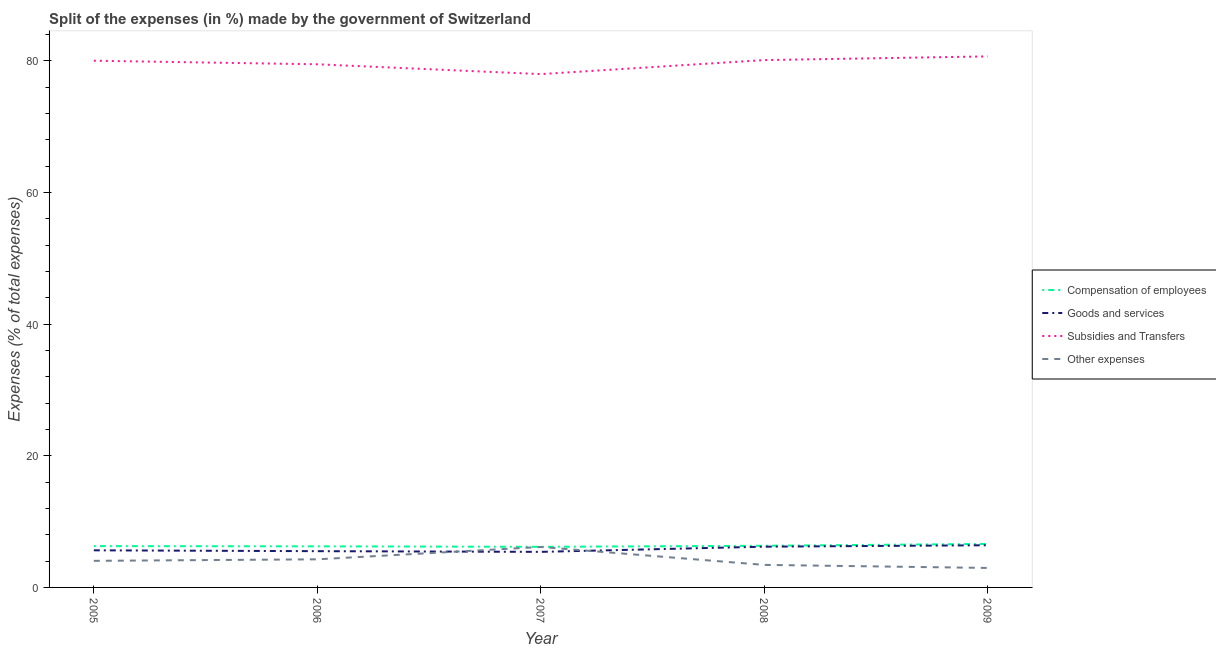How many different coloured lines are there?
Make the answer very short. 4. Does the line corresponding to percentage of amount spent on compensation of employees intersect with the line corresponding to percentage of amount spent on other expenses?
Provide a short and direct response. No. Is the number of lines equal to the number of legend labels?
Offer a very short reply. Yes. What is the percentage of amount spent on compensation of employees in 2007?
Offer a terse response. 6.17. Across all years, what is the maximum percentage of amount spent on compensation of employees?
Give a very brief answer. 6.61. Across all years, what is the minimum percentage of amount spent on other expenses?
Your answer should be compact. 2.96. In which year was the percentage of amount spent on compensation of employees maximum?
Ensure brevity in your answer.  2009. What is the total percentage of amount spent on subsidies in the graph?
Ensure brevity in your answer.  398.27. What is the difference between the percentage of amount spent on subsidies in 2008 and that in 2009?
Keep it short and to the point. -0.56. What is the difference between the percentage of amount spent on other expenses in 2009 and the percentage of amount spent on goods and services in 2005?
Your answer should be compact. -2.68. What is the average percentage of amount spent on goods and services per year?
Ensure brevity in your answer.  5.83. In the year 2006, what is the difference between the percentage of amount spent on other expenses and percentage of amount spent on compensation of employees?
Ensure brevity in your answer.  -1.97. What is the ratio of the percentage of amount spent on subsidies in 2007 to that in 2009?
Your answer should be very brief. 0.97. Is the difference between the percentage of amount spent on goods and services in 2006 and 2007 greater than the difference between the percentage of amount spent on other expenses in 2006 and 2007?
Your response must be concise. Yes. What is the difference between the highest and the second highest percentage of amount spent on compensation of employees?
Make the answer very short. 0.28. What is the difference between the highest and the lowest percentage of amount spent on compensation of employees?
Keep it short and to the point. 0.44. In how many years, is the percentage of amount spent on other expenses greater than the average percentage of amount spent on other expenses taken over all years?
Your response must be concise. 2. Is it the case that in every year, the sum of the percentage of amount spent on compensation of employees and percentage of amount spent on other expenses is greater than the sum of percentage of amount spent on subsidies and percentage of amount spent on goods and services?
Keep it short and to the point. No. Is it the case that in every year, the sum of the percentage of amount spent on compensation of employees and percentage of amount spent on goods and services is greater than the percentage of amount spent on subsidies?
Ensure brevity in your answer.  No. How many lines are there?
Ensure brevity in your answer.  4. How many years are there in the graph?
Make the answer very short. 5. What is the difference between two consecutive major ticks on the Y-axis?
Ensure brevity in your answer.  20. Does the graph contain any zero values?
Your answer should be very brief. No. Where does the legend appear in the graph?
Offer a very short reply. Center right. How many legend labels are there?
Your answer should be compact. 4. How are the legend labels stacked?
Your answer should be very brief. Vertical. What is the title of the graph?
Offer a very short reply. Split of the expenses (in %) made by the government of Switzerland. Does "Coal" appear as one of the legend labels in the graph?
Offer a very short reply. No. What is the label or title of the X-axis?
Give a very brief answer. Year. What is the label or title of the Y-axis?
Keep it short and to the point. Expenses (% of total expenses). What is the Expenses (% of total expenses) of Compensation of employees in 2005?
Provide a succinct answer. 6.28. What is the Expenses (% of total expenses) in Goods and services in 2005?
Give a very brief answer. 5.64. What is the Expenses (% of total expenses) of Subsidies and Transfers in 2005?
Keep it short and to the point. 80.02. What is the Expenses (% of total expenses) of Other expenses in 2005?
Give a very brief answer. 4.04. What is the Expenses (% of total expenses) of Compensation of employees in 2006?
Provide a succinct answer. 6.24. What is the Expenses (% of total expenses) of Goods and services in 2006?
Provide a short and direct response. 5.51. What is the Expenses (% of total expenses) in Subsidies and Transfers in 2006?
Provide a succinct answer. 79.48. What is the Expenses (% of total expenses) of Other expenses in 2006?
Your response must be concise. 4.27. What is the Expenses (% of total expenses) in Compensation of employees in 2007?
Provide a succinct answer. 6.17. What is the Expenses (% of total expenses) in Goods and services in 2007?
Provide a succinct answer. 5.4. What is the Expenses (% of total expenses) of Subsidies and Transfers in 2007?
Your answer should be compact. 77.99. What is the Expenses (% of total expenses) of Other expenses in 2007?
Your response must be concise. 6.15. What is the Expenses (% of total expenses) in Compensation of employees in 2008?
Provide a succinct answer. 6.33. What is the Expenses (% of total expenses) in Goods and services in 2008?
Your response must be concise. 6.19. What is the Expenses (% of total expenses) in Subsidies and Transfers in 2008?
Make the answer very short. 80.12. What is the Expenses (% of total expenses) in Other expenses in 2008?
Make the answer very short. 3.42. What is the Expenses (% of total expenses) in Compensation of employees in 2009?
Ensure brevity in your answer.  6.61. What is the Expenses (% of total expenses) in Goods and services in 2009?
Your response must be concise. 6.41. What is the Expenses (% of total expenses) in Subsidies and Transfers in 2009?
Give a very brief answer. 80.68. What is the Expenses (% of total expenses) of Other expenses in 2009?
Keep it short and to the point. 2.96. Across all years, what is the maximum Expenses (% of total expenses) of Compensation of employees?
Your answer should be compact. 6.61. Across all years, what is the maximum Expenses (% of total expenses) in Goods and services?
Provide a succinct answer. 6.41. Across all years, what is the maximum Expenses (% of total expenses) of Subsidies and Transfers?
Give a very brief answer. 80.68. Across all years, what is the maximum Expenses (% of total expenses) in Other expenses?
Keep it short and to the point. 6.15. Across all years, what is the minimum Expenses (% of total expenses) of Compensation of employees?
Make the answer very short. 6.17. Across all years, what is the minimum Expenses (% of total expenses) in Goods and services?
Offer a terse response. 5.4. Across all years, what is the minimum Expenses (% of total expenses) of Subsidies and Transfers?
Provide a short and direct response. 77.99. Across all years, what is the minimum Expenses (% of total expenses) of Other expenses?
Offer a terse response. 2.96. What is the total Expenses (% of total expenses) in Compensation of employees in the graph?
Ensure brevity in your answer.  31.63. What is the total Expenses (% of total expenses) in Goods and services in the graph?
Make the answer very short. 29.15. What is the total Expenses (% of total expenses) of Subsidies and Transfers in the graph?
Provide a succinct answer. 398.27. What is the total Expenses (% of total expenses) of Other expenses in the graph?
Provide a short and direct response. 20.84. What is the difference between the Expenses (% of total expenses) of Compensation of employees in 2005 and that in 2006?
Make the answer very short. 0.03. What is the difference between the Expenses (% of total expenses) of Goods and services in 2005 and that in 2006?
Offer a terse response. 0.13. What is the difference between the Expenses (% of total expenses) in Subsidies and Transfers in 2005 and that in 2006?
Make the answer very short. 0.54. What is the difference between the Expenses (% of total expenses) in Other expenses in 2005 and that in 2006?
Your response must be concise. -0.23. What is the difference between the Expenses (% of total expenses) of Compensation of employees in 2005 and that in 2007?
Give a very brief answer. 0.11. What is the difference between the Expenses (% of total expenses) in Goods and services in 2005 and that in 2007?
Offer a very short reply. 0.23. What is the difference between the Expenses (% of total expenses) of Subsidies and Transfers in 2005 and that in 2007?
Offer a very short reply. 2.03. What is the difference between the Expenses (% of total expenses) in Other expenses in 2005 and that in 2007?
Give a very brief answer. -2.11. What is the difference between the Expenses (% of total expenses) in Compensation of employees in 2005 and that in 2008?
Offer a terse response. -0.05. What is the difference between the Expenses (% of total expenses) in Goods and services in 2005 and that in 2008?
Offer a terse response. -0.55. What is the difference between the Expenses (% of total expenses) of Subsidies and Transfers in 2005 and that in 2008?
Offer a terse response. -0.1. What is the difference between the Expenses (% of total expenses) in Other expenses in 2005 and that in 2008?
Your response must be concise. 0.61. What is the difference between the Expenses (% of total expenses) of Compensation of employees in 2005 and that in 2009?
Your answer should be compact. -0.33. What is the difference between the Expenses (% of total expenses) in Goods and services in 2005 and that in 2009?
Provide a short and direct response. -0.77. What is the difference between the Expenses (% of total expenses) in Subsidies and Transfers in 2005 and that in 2009?
Provide a succinct answer. -0.66. What is the difference between the Expenses (% of total expenses) in Other expenses in 2005 and that in 2009?
Provide a short and direct response. 1.08. What is the difference between the Expenses (% of total expenses) of Compensation of employees in 2006 and that in 2007?
Offer a very short reply. 0.08. What is the difference between the Expenses (% of total expenses) of Goods and services in 2006 and that in 2007?
Offer a very short reply. 0.11. What is the difference between the Expenses (% of total expenses) of Subsidies and Transfers in 2006 and that in 2007?
Offer a terse response. 1.49. What is the difference between the Expenses (% of total expenses) of Other expenses in 2006 and that in 2007?
Your answer should be compact. -1.88. What is the difference between the Expenses (% of total expenses) in Compensation of employees in 2006 and that in 2008?
Ensure brevity in your answer.  -0.09. What is the difference between the Expenses (% of total expenses) in Goods and services in 2006 and that in 2008?
Ensure brevity in your answer.  -0.68. What is the difference between the Expenses (% of total expenses) in Subsidies and Transfers in 2006 and that in 2008?
Ensure brevity in your answer.  -0.64. What is the difference between the Expenses (% of total expenses) in Other expenses in 2006 and that in 2008?
Offer a very short reply. 0.84. What is the difference between the Expenses (% of total expenses) of Compensation of employees in 2006 and that in 2009?
Give a very brief answer. -0.36. What is the difference between the Expenses (% of total expenses) in Goods and services in 2006 and that in 2009?
Provide a succinct answer. -0.9. What is the difference between the Expenses (% of total expenses) in Subsidies and Transfers in 2006 and that in 2009?
Ensure brevity in your answer.  -1.2. What is the difference between the Expenses (% of total expenses) of Other expenses in 2006 and that in 2009?
Keep it short and to the point. 1.31. What is the difference between the Expenses (% of total expenses) of Compensation of employees in 2007 and that in 2008?
Provide a short and direct response. -0.16. What is the difference between the Expenses (% of total expenses) of Goods and services in 2007 and that in 2008?
Make the answer very short. -0.79. What is the difference between the Expenses (% of total expenses) of Subsidies and Transfers in 2007 and that in 2008?
Your response must be concise. -2.13. What is the difference between the Expenses (% of total expenses) of Other expenses in 2007 and that in 2008?
Provide a succinct answer. 2.72. What is the difference between the Expenses (% of total expenses) of Compensation of employees in 2007 and that in 2009?
Keep it short and to the point. -0.44. What is the difference between the Expenses (% of total expenses) in Goods and services in 2007 and that in 2009?
Your answer should be compact. -1. What is the difference between the Expenses (% of total expenses) of Subsidies and Transfers in 2007 and that in 2009?
Provide a short and direct response. -2.69. What is the difference between the Expenses (% of total expenses) of Other expenses in 2007 and that in 2009?
Your answer should be very brief. 3.19. What is the difference between the Expenses (% of total expenses) in Compensation of employees in 2008 and that in 2009?
Offer a terse response. -0.28. What is the difference between the Expenses (% of total expenses) of Goods and services in 2008 and that in 2009?
Provide a succinct answer. -0.22. What is the difference between the Expenses (% of total expenses) in Subsidies and Transfers in 2008 and that in 2009?
Provide a short and direct response. -0.56. What is the difference between the Expenses (% of total expenses) in Other expenses in 2008 and that in 2009?
Ensure brevity in your answer.  0.46. What is the difference between the Expenses (% of total expenses) of Compensation of employees in 2005 and the Expenses (% of total expenses) of Goods and services in 2006?
Offer a very short reply. 0.77. What is the difference between the Expenses (% of total expenses) of Compensation of employees in 2005 and the Expenses (% of total expenses) of Subsidies and Transfers in 2006?
Provide a short and direct response. -73.2. What is the difference between the Expenses (% of total expenses) of Compensation of employees in 2005 and the Expenses (% of total expenses) of Other expenses in 2006?
Ensure brevity in your answer.  2.01. What is the difference between the Expenses (% of total expenses) in Goods and services in 2005 and the Expenses (% of total expenses) in Subsidies and Transfers in 2006?
Offer a terse response. -73.84. What is the difference between the Expenses (% of total expenses) of Goods and services in 2005 and the Expenses (% of total expenses) of Other expenses in 2006?
Ensure brevity in your answer.  1.37. What is the difference between the Expenses (% of total expenses) of Subsidies and Transfers in 2005 and the Expenses (% of total expenses) of Other expenses in 2006?
Your answer should be compact. 75.75. What is the difference between the Expenses (% of total expenses) in Compensation of employees in 2005 and the Expenses (% of total expenses) in Goods and services in 2007?
Your answer should be very brief. 0.88. What is the difference between the Expenses (% of total expenses) in Compensation of employees in 2005 and the Expenses (% of total expenses) in Subsidies and Transfers in 2007?
Offer a terse response. -71.71. What is the difference between the Expenses (% of total expenses) of Compensation of employees in 2005 and the Expenses (% of total expenses) of Other expenses in 2007?
Give a very brief answer. 0.13. What is the difference between the Expenses (% of total expenses) of Goods and services in 2005 and the Expenses (% of total expenses) of Subsidies and Transfers in 2007?
Your answer should be very brief. -72.35. What is the difference between the Expenses (% of total expenses) of Goods and services in 2005 and the Expenses (% of total expenses) of Other expenses in 2007?
Keep it short and to the point. -0.51. What is the difference between the Expenses (% of total expenses) in Subsidies and Transfers in 2005 and the Expenses (% of total expenses) in Other expenses in 2007?
Ensure brevity in your answer.  73.87. What is the difference between the Expenses (% of total expenses) in Compensation of employees in 2005 and the Expenses (% of total expenses) in Goods and services in 2008?
Make the answer very short. 0.09. What is the difference between the Expenses (% of total expenses) of Compensation of employees in 2005 and the Expenses (% of total expenses) of Subsidies and Transfers in 2008?
Give a very brief answer. -73.84. What is the difference between the Expenses (% of total expenses) of Compensation of employees in 2005 and the Expenses (% of total expenses) of Other expenses in 2008?
Keep it short and to the point. 2.85. What is the difference between the Expenses (% of total expenses) of Goods and services in 2005 and the Expenses (% of total expenses) of Subsidies and Transfers in 2008?
Your answer should be compact. -74.48. What is the difference between the Expenses (% of total expenses) of Goods and services in 2005 and the Expenses (% of total expenses) of Other expenses in 2008?
Give a very brief answer. 2.21. What is the difference between the Expenses (% of total expenses) in Subsidies and Transfers in 2005 and the Expenses (% of total expenses) in Other expenses in 2008?
Your answer should be compact. 76.6. What is the difference between the Expenses (% of total expenses) of Compensation of employees in 2005 and the Expenses (% of total expenses) of Goods and services in 2009?
Ensure brevity in your answer.  -0.13. What is the difference between the Expenses (% of total expenses) in Compensation of employees in 2005 and the Expenses (% of total expenses) in Subsidies and Transfers in 2009?
Your answer should be compact. -74.4. What is the difference between the Expenses (% of total expenses) of Compensation of employees in 2005 and the Expenses (% of total expenses) of Other expenses in 2009?
Your response must be concise. 3.32. What is the difference between the Expenses (% of total expenses) of Goods and services in 2005 and the Expenses (% of total expenses) of Subsidies and Transfers in 2009?
Offer a terse response. -75.04. What is the difference between the Expenses (% of total expenses) in Goods and services in 2005 and the Expenses (% of total expenses) in Other expenses in 2009?
Offer a very short reply. 2.68. What is the difference between the Expenses (% of total expenses) in Subsidies and Transfers in 2005 and the Expenses (% of total expenses) in Other expenses in 2009?
Your response must be concise. 77.06. What is the difference between the Expenses (% of total expenses) in Compensation of employees in 2006 and the Expenses (% of total expenses) in Goods and services in 2007?
Your answer should be compact. 0.84. What is the difference between the Expenses (% of total expenses) of Compensation of employees in 2006 and the Expenses (% of total expenses) of Subsidies and Transfers in 2007?
Give a very brief answer. -71.74. What is the difference between the Expenses (% of total expenses) in Compensation of employees in 2006 and the Expenses (% of total expenses) in Other expenses in 2007?
Give a very brief answer. 0.1. What is the difference between the Expenses (% of total expenses) of Goods and services in 2006 and the Expenses (% of total expenses) of Subsidies and Transfers in 2007?
Provide a short and direct response. -72.48. What is the difference between the Expenses (% of total expenses) in Goods and services in 2006 and the Expenses (% of total expenses) in Other expenses in 2007?
Your answer should be very brief. -0.64. What is the difference between the Expenses (% of total expenses) of Subsidies and Transfers in 2006 and the Expenses (% of total expenses) of Other expenses in 2007?
Offer a terse response. 73.33. What is the difference between the Expenses (% of total expenses) in Compensation of employees in 2006 and the Expenses (% of total expenses) in Goods and services in 2008?
Your response must be concise. 0.05. What is the difference between the Expenses (% of total expenses) in Compensation of employees in 2006 and the Expenses (% of total expenses) in Subsidies and Transfers in 2008?
Offer a terse response. -73.87. What is the difference between the Expenses (% of total expenses) in Compensation of employees in 2006 and the Expenses (% of total expenses) in Other expenses in 2008?
Your answer should be compact. 2.82. What is the difference between the Expenses (% of total expenses) in Goods and services in 2006 and the Expenses (% of total expenses) in Subsidies and Transfers in 2008?
Offer a terse response. -74.61. What is the difference between the Expenses (% of total expenses) of Goods and services in 2006 and the Expenses (% of total expenses) of Other expenses in 2008?
Provide a succinct answer. 2.08. What is the difference between the Expenses (% of total expenses) of Subsidies and Transfers in 2006 and the Expenses (% of total expenses) of Other expenses in 2008?
Offer a terse response. 76.05. What is the difference between the Expenses (% of total expenses) of Compensation of employees in 2006 and the Expenses (% of total expenses) of Goods and services in 2009?
Your answer should be very brief. -0.16. What is the difference between the Expenses (% of total expenses) of Compensation of employees in 2006 and the Expenses (% of total expenses) of Subsidies and Transfers in 2009?
Offer a very short reply. -74.43. What is the difference between the Expenses (% of total expenses) of Compensation of employees in 2006 and the Expenses (% of total expenses) of Other expenses in 2009?
Your answer should be very brief. 3.28. What is the difference between the Expenses (% of total expenses) in Goods and services in 2006 and the Expenses (% of total expenses) in Subsidies and Transfers in 2009?
Your response must be concise. -75.17. What is the difference between the Expenses (% of total expenses) in Goods and services in 2006 and the Expenses (% of total expenses) in Other expenses in 2009?
Your response must be concise. 2.55. What is the difference between the Expenses (% of total expenses) of Subsidies and Transfers in 2006 and the Expenses (% of total expenses) of Other expenses in 2009?
Ensure brevity in your answer.  76.51. What is the difference between the Expenses (% of total expenses) of Compensation of employees in 2007 and the Expenses (% of total expenses) of Goods and services in 2008?
Offer a terse response. -0.02. What is the difference between the Expenses (% of total expenses) in Compensation of employees in 2007 and the Expenses (% of total expenses) in Subsidies and Transfers in 2008?
Offer a terse response. -73.95. What is the difference between the Expenses (% of total expenses) in Compensation of employees in 2007 and the Expenses (% of total expenses) in Other expenses in 2008?
Your answer should be compact. 2.74. What is the difference between the Expenses (% of total expenses) in Goods and services in 2007 and the Expenses (% of total expenses) in Subsidies and Transfers in 2008?
Offer a terse response. -74.71. What is the difference between the Expenses (% of total expenses) in Goods and services in 2007 and the Expenses (% of total expenses) in Other expenses in 2008?
Provide a short and direct response. 1.98. What is the difference between the Expenses (% of total expenses) in Subsidies and Transfers in 2007 and the Expenses (% of total expenses) in Other expenses in 2008?
Provide a short and direct response. 74.56. What is the difference between the Expenses (% of total expenses) of Compensation of employees in 2007 and the Expenses (% of total expenses) of Goods and services in 2009?
Provide a succinct answer. -0.24. What is the difference between the Expenses (% of total expenses) of Compensation of employees in 2007 and the Expenses (% of total expenses) of Subsidies and Transfers in 2009?
Ensure brevity in your answer.  -74.51. What is the difference between the Expenses (% of total expenses) of Compensation of employees in 2007 and the Expenses (% of total expenses) of Other expenses in 2009?
Offer a terse response. 3.21. What is the difference between the Expenses (% of total expenses) of Goods and services in 2007 and the Expenses (% of total expenses) of Subsidies and Transfers in 2009?
Provide a short and direct response. -75.27. What is the difference between the Expenses (% of total expenses) of Goods and services in 2007 and the Expenses (% of total expenses) of Other expenses in 2009?
Offer a very short reply. 2.44. What is the difference between the Expenses (% of total expenses) of Subsidies and Transfers in 2007 and the Expenses (% of total expenses) of Other expenses in 2009?
Keep it short and to the point. 75.03. What is the difference between the Expenses (% of total expenses) in Compensation of employees in 2008 and the Expenses (% of total expenses) in Goods and services in 2009?
Your response must be concise. -0.08. What is the difference between the Expenses (% of total expenses) of Compensation of employees in 2008 and the Expenses (% of total expenses) of Subsidies and Transfers in 2009?
Make the answer very short. -74.35. What is the difference between the Expenses (% of total expenses) of Compensation of employees in 2008 and the Expenses (% of total expenses) of Other expenses in 2009?
Your answer should be compact. 3.37. What is the difference between the Expenses (% of total expenses) of Goods and services in 2008 and the Expenses (% of total expenses) of Subsidies and Transfers in 2009?
Provide a succinct answer. -74.49. What is the difference between the Expenses (% of total expenses) in Goods and services in 2008 and the Expenses (% of total expenses) in Other expenses in 2009?
Your answer should be compact. 3.23. What is the difference between the Expenses (% of total expenses) in Subsidies and Transfers in 2008 and the Expenses (% of total expenses) in Other expenses in 2009?
Keep it short and to the point. 77.15. What is the average Expenses (% of total expenses) in Compensation of employees per year?
Your answer should be compact. 6.33. What is the average Expenses (% of total expenses) in Goods and services per year?
Keep it short and to the point. 5.83. What is the average Expenses (% of total expenses) of Subsidies and Transfers per year?
Make the answer very short. 79.65. What is the average Expenses (% of total expenses) in Other expenses per year?
Your answer should be compact. 4.17. In the year 2005, what is the difference between the Expenses (% of total expenses) of Compensation of employees and Expenses (% of total expenses) of Goods and services?
Keep it short and to the point. 0.64. In the year 2005, what is the difference between the Expenses (% of total expenses) in Compensation of employees and Expenses (% of total expenses) in Subsidies and Transfers?
Offer a terse response. -73.74. In the year 2005, what is the difference between the Expenses (% of total expenses) in Compensation of employees and Expenses (% of total expenses) in Other expenses?
Provide a short and direct response. 2.24. In the year 2005, what is the difference between the Expenses (% of total expenses) in Goods and services and Expenses (% of total expenses) in Subsidies and Transfers?
Your response must be concise. -74.38. In the year 2005, what is the difference between the Expenses (% of total expenses) in Goods and services and Expenses (% of total expenses) in Other expenses?
Provide a succinct answer. 1.6. In the year 2005, what is the difference between the Expenses (% of total expenses) in Subsidies and Transfers and Expenses (% of total expenses) in Other expenses?
Provide a succinct answer. 75.98. In the year 2006, what is the difference between the Expenses (% of total expenses) of Compensation of employees and Expenses (% of total expenses) of Goods and services?
Provide a succinct answer. 0.74. In the year 2006, what is the difference between the Expenses (% of total expenses) of Compensation of employees and Expenses (% of total expenses) of Subsidies and Transfers?
Ensure brevity in your answer.  -73.23. In the year 2006, what is the difference between the Expenses (% of total expenses) in Compensation of employees and Expenses (% of total expenses) in Other expenses?
Keep it short and to the point. 1.97. In the year 2006, what is the difference between the Expenses (% of total expenses) in Goods and services and Expenses (% of total expenses) in Subsidies and Transfers?
Your answer should be compact. -73.97. In the year 2006, what is the difference between the Expenses (% of total expenses) of Goods and services and Expenses (% of total expenses) of Other expenses?
Provide a succinct answer. 1.24. In the year 2006, what is the difference between the Expenses (% of total expenses) in Subsidies and Transfers and Expenses (% of total expenses) in Other expenses?
Provide a succinct answer. 75.21. In the year 2007, what is the difference between the Expenses (% of total expenses) in Compensation of employees and Expenses (% of total expenses) in Goods and services?
Give a very brief answer. 0.76. In the year 2007, what is the difference between the Expenses (% of total expenses) in Compensation of employees and Expenses (% of total expenses) in Subsidies and Transfers?
Offer a very short reply. -71.82. In the year 2007, what is the difference between the Expenses (% of total expenses) of Compensation of employees and Expenses (% of total expenses) of Other expenses?
Provide a succinct answer. 0.02. In the year 2007, what is the difference between the Expenses (% of total expenses) of Goods and services and Expenses (% of total expenses) of Subsidies and Transfers?
Make the answer very short. -72.58. In the year 2007, what is the difference between the Expenses (% of total expenses) of Goods and services and Expenses (% of total expenses) of Other expenses?
Your response must be concise. -0.74. In the year 2007, what is the difference between the Expenses (% of total expenses) in Subsidies and Transfers and Expenses (% of total expenses) in Other expenses?
Offer a terse response. 71.84. In the year 2008, what is the difference between the Expenses (% of total expenses) in Compensation of employees and Expenses (% of total expenses) in Goods and services?
Your answer should be compact. 0.14. In the year 2008, what is the difference between the Expenses (% of total expenses) in Compensation of employees and Expenses (% of total expenses) in Subsidies and Transfers?
Ensure brevity in your answer.  -73.78. In the year 2008, what is the difference between the Expenses (% of total expenses) in Compensation of employees and Expenses (% of total expenses) in Other expenses?
Your answer should be very brief. 2.91. In the year 2008, what is the difference between the Expenses (% of total expenses) in Goods and services and Expenses (% of total expenses) in Subsidies and Transfers?
Give a very brief answer. -73.93. In the year 2008, what is the difference between the Expenses (% of total expenses) in Goods and services and Expenses (% of total expenses) in Other expenses?
Offer a terse response. 2.77. In the year 2008, what is the difference between the Expenses (% of total expenses) in Subsidies and Transfers and Expenses (% of total expenses) in Other expenses?
Offer a terse response. 76.69. In the year 2009, what is the difference between the Expenses (% of total expenses) in Compensation of employees and Expenses (% of total expenses) in Goods and services?
Ensure brevity in your answer.  0.2. In the year 2009, what is the difference between the Expenses (% of total expenses) of Compensation of employees and Expenses (% of total expenses) of Subsidies and Transfers?
Offer a terse response. -74.07. In the year 2009, what is the difference between the Expenses (% of total expenses) of Compensation of employees and Expenses (% of total expenses) of Other expenses?
Offer a terse response. 3.65. In the year 2009, what is the difference between the Expenses (% of total expenses) in Goods and services and Expenses (% of total expenses) in Subsidies and Transfers?
Ensure brevity in your answer.  -74.27. In the year 2009, what is the difference between the Expenses (% of total expenses) in Goods and services and Expenses (% of total expenses) in Other expenses?
Your answer should be compact. 3.45. In the year 2009, what is the difference between the Expenses (% of total expenses) in Subsidies and Transfers and Expenses (% of total expenses) in Other expenses?
Provide a succinct answer. 77.71. What is the ratio of the Expenses (% of total expenses) of Compensation of employees in 2005 to that in 2006?
Provide a short and direct response. 1.01. What is the ratio of the Expenses (% of total expenses) of Goods and services in 2005 to that in 2006?
Your answer should be compact. 1.02. What is the ratio of the Expenses (% of total expenses) in Subsidies and Transfers in 2005 to that in 2006?
Offer a very short reply. 1.01. What is the ratio of the Expenses (% of total expenses) of Other expenses in 2005 to that in 2006?
Your answer should be very brief. 0.95. What is the ratio of the Expenses (% of total expenses) of Compensation of employees in 2005 to that in 2007?
Keep it short and to the point. 1.02. What is the ratio of the Expenses (% of total expenses) in Goods and services in 2005 to that in 2007?
Provide a succinct answer. 1.04. What is the ratio of the Expenses (% of total expenses) in Subsidies and Transfers in 2005 to that in 2007?
Offer a very short reply. 1.03. What is the ratio of the Expenses (% of total expenses) of Other expenses in 2005 to that in 2007?
Give a very brief answer. 0.66. What is the ratio of the Expenses (% of total expenses) of Goods and services in 2005 to that in 2008?
Offer a very short reply. 0.91. What is the ratio of the Expenses (% of total expenses) of Other expenses in 2005 to that in 2008?
Provide a short and direct response. 1.18. What is the ratio of the Expenses (% of total expenses) in Compensation of employees in 2005 to that in 2009?
Provide a short and direct response. 0.95. What is the ratio of the Expenses (% of total expenses) in Goods and services in 2005 to that in 2009?
Your answer should be very brief. 0.88. What is the ratio of the Expenses (% of total expenses) of Subsidies and Transfers in 2005 to that in 2009?
Make the answer very short. 0.99. What is the ratio of the Expenses (% of total expenses) in Other expenses in 2005 to that in 2009?
Give a very brief answer. 1.36. What is the ratio of the Expenses (% of total expenses) in Compensation of employees in 2006 to that in 2007?
Offer a terse response. 1.01. What is the ratio of the Expenses (% of total expenses) in Goods and services in 2006 to that in 2007?
Offer a terse response. 1.02. What is the ratio of the Expenses (% of total expenses) of Subsidies and Transfers in 2006 to that in 2007?
Your answer should be very brief. 1.02. What is the ratio of the Expenses (% of total expenses) of Other expenses in 2006 to that in 2007?
Your answer should be compact. 0.69. What is the ratio of the Expenses (% of total expenses) in Compensation of employees in 2006 to that in 2008?
Your response must be concise. 0.99. What is the ratio of the Expenses (% of total expenses) in Goods and services in 2006 to that in 2008?
Make the answer very short. 0.89. What is the ratio of the Expenses (% of total expenses) of Subsidies and Transfers in 2006 to that in 2008?
Provide a short and direct response. 0.99. What is the ratio of the Expenses (% of total expenses) of Other expenses in 2006 to that in 2008?
Keep it short and to the point. 1.25. What is the ratio of the Expenses (% of total expenses) of Compensation of employees in 2006 to that in 2009?
Your answer should be compact. 0.94. What is the ratio of the Expenses (% of total expenses) in Goods and services in 2006 to that in 2009?
Your answer should be very brief. 0.86. What is the ratio of the Expenses (% of total expenses) of Subsidies and Transfers in 2006 to that in 2009?
Give a very brief answer. 0.99. What is the ratio of the Expenses (% of total expenses) of Other expenses in 2006 to that in 2009?
Keep it short and to the point. 1.44. What is the ratio of the Expenses (% of total expenses) of Compensation of employees in 2007 to that in 2008?
Provide a short and direct response. 0.97. What is the ratio of the Expenses (% of total expenses) of Goods and services in 2007 to that in 2008?
Offer a very short reply. 0.87. What is the ratio of the Expenses (% of total expenses) in Subsidies and Transfers in 2007 to that in 2008?
Provide a succinct answer. 0.97. What is the ratio of the Expenses (% of total expenses) in Other expenses in 2007 to that in 2008?
Provide a succinct answer. 1.79. What is the ratio of the Expenses (% of total expenses) of Compensation of employees in 2007 to that in 2009?
Your answer should be very brief. 0.93. What is the ratio of the Expenses (% of total expenses) of Goods and services in 2007 to that in 2009?
Your answer should be compact. 0.84. What is the ratio of the Expenses (% of total expenses) of Subsidies and Transfers in 2007 to that in 2009?
Your response must be concise. 0.97. What is the ratio of the Expenses (% of total expenses) in Other expenses in 2007 to that in 2009?
Provide a succinct answer. 2.08. What is the ratio of the Expenses (% of total expenses) of Compensation of employees in 2008 to that in 2009?
Your response must be concise. 0.96. What is the ratio of the Expenses (% of total expenses) in Goods and services in 2008 to that in 2009?
Offer a very short reply. 0.97. What is the ratio of the Expenses (% of total expenses) of Subsidies and Transfers in 2008 to that in 2009?
Keep it short and to the point. 0.99. What is the ratio of the Expenses (% of total expenses) in Other expenses in 2008 to that in 2009?
Your answer should be very brief. 1.16. What is the difference between the highest and the second highest Expenses (% of total expenses) in Compensation of employees?
Your response must be concise. 0.28. What is the difference between the highest and the second highest Expenses (% of total expenses) in Goods and services?
Your response must be concise. 0.22. What is the difference between the highest and the second highest Expenses (% of total expenses) of Subsidies and Transfers?
Your answer should be compact. 0.56. What is the difference between the highest and the second highest Expenses (% of total expenses) in Other expenses?
Make the answer very short. 1.88. What is the difference between the highest and the lowest Expenses (% of total expenses) in Compensation of employees?
Your answer should be compact. 0.44. What is the difference between the highest and the lowest Expenses (% of total expenses) in Goods and services?
Offer a terse response. 1. What is the difference between the highest and the lowest Expenses (% of total expenses) of Subsidies and Transfers?
Ensure brevity in your answer.  2.69. What is the difference between the highest and the lowest Expenses (% of total expenses) in Other expenses?
Your response must be concise. 3.19. 